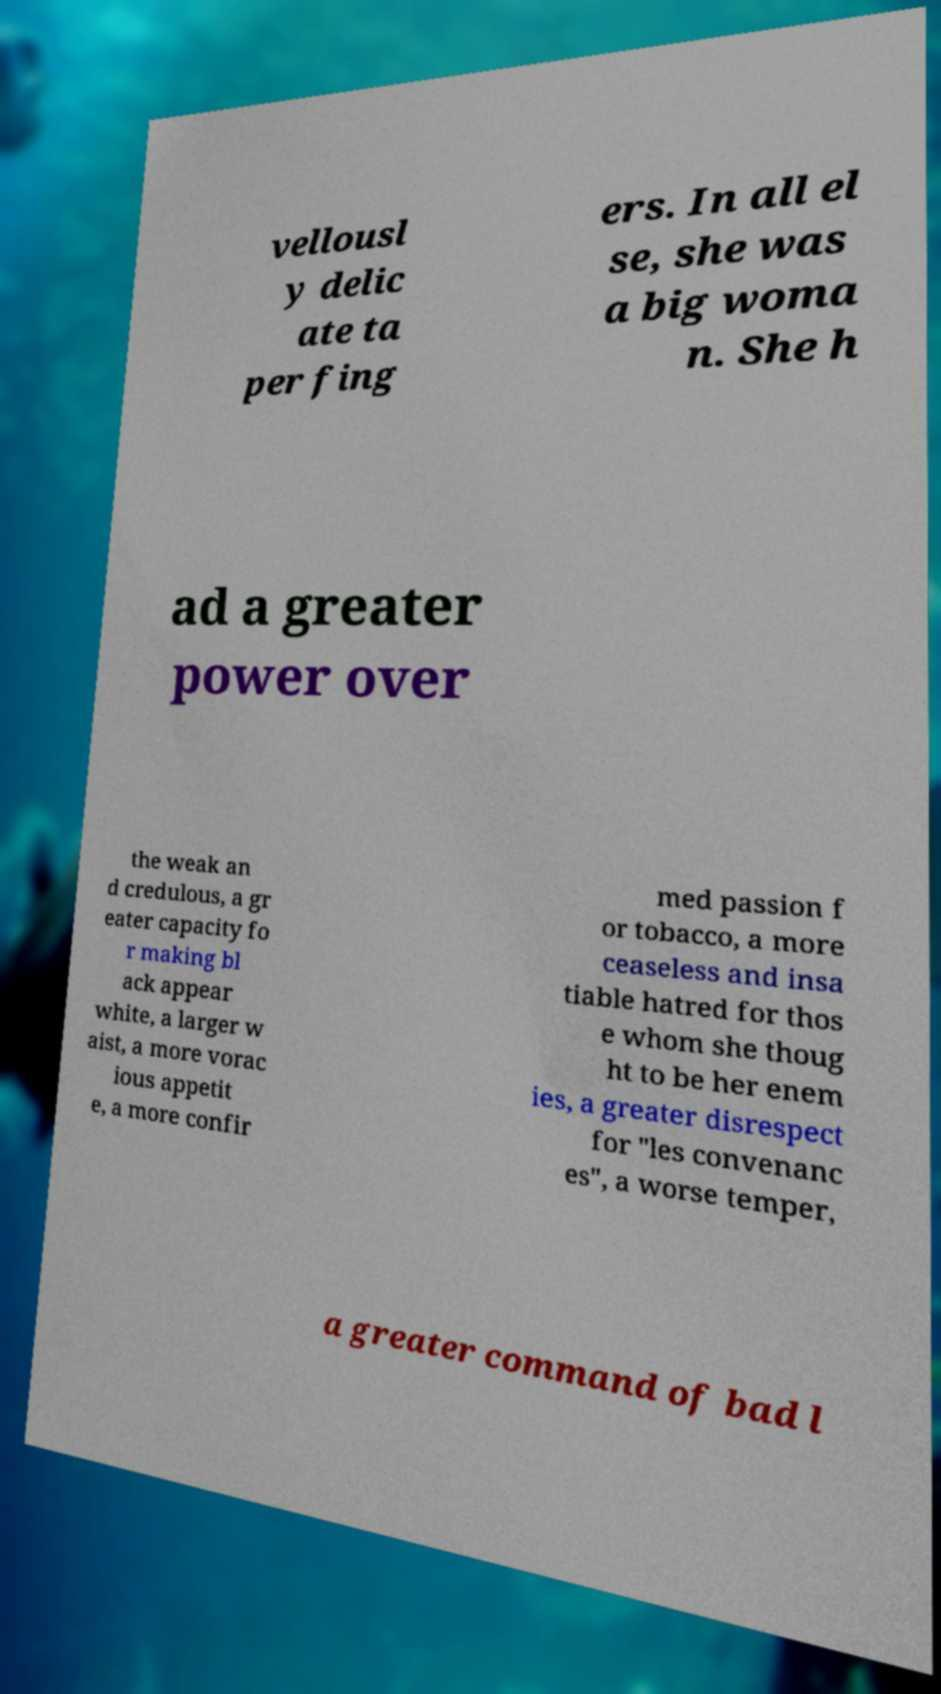Please read and relay the text visible in this image. What does it say? vellousl y delic ate ta per fing ers. In all el se, she was a big woma n. She h ad a greater power over the weak an d credulous, a gr eater capacity fo r making bl ack appear white, a larger w aist, a more vorac ious appetit e, a more confir med passion f or tobacco, a more ceaseless and insa tiable hatred for thos e whom she thoug ht to be her enem ies, a greater disrespect for "les convenanc es", a worse temper, a greater command of bad l 